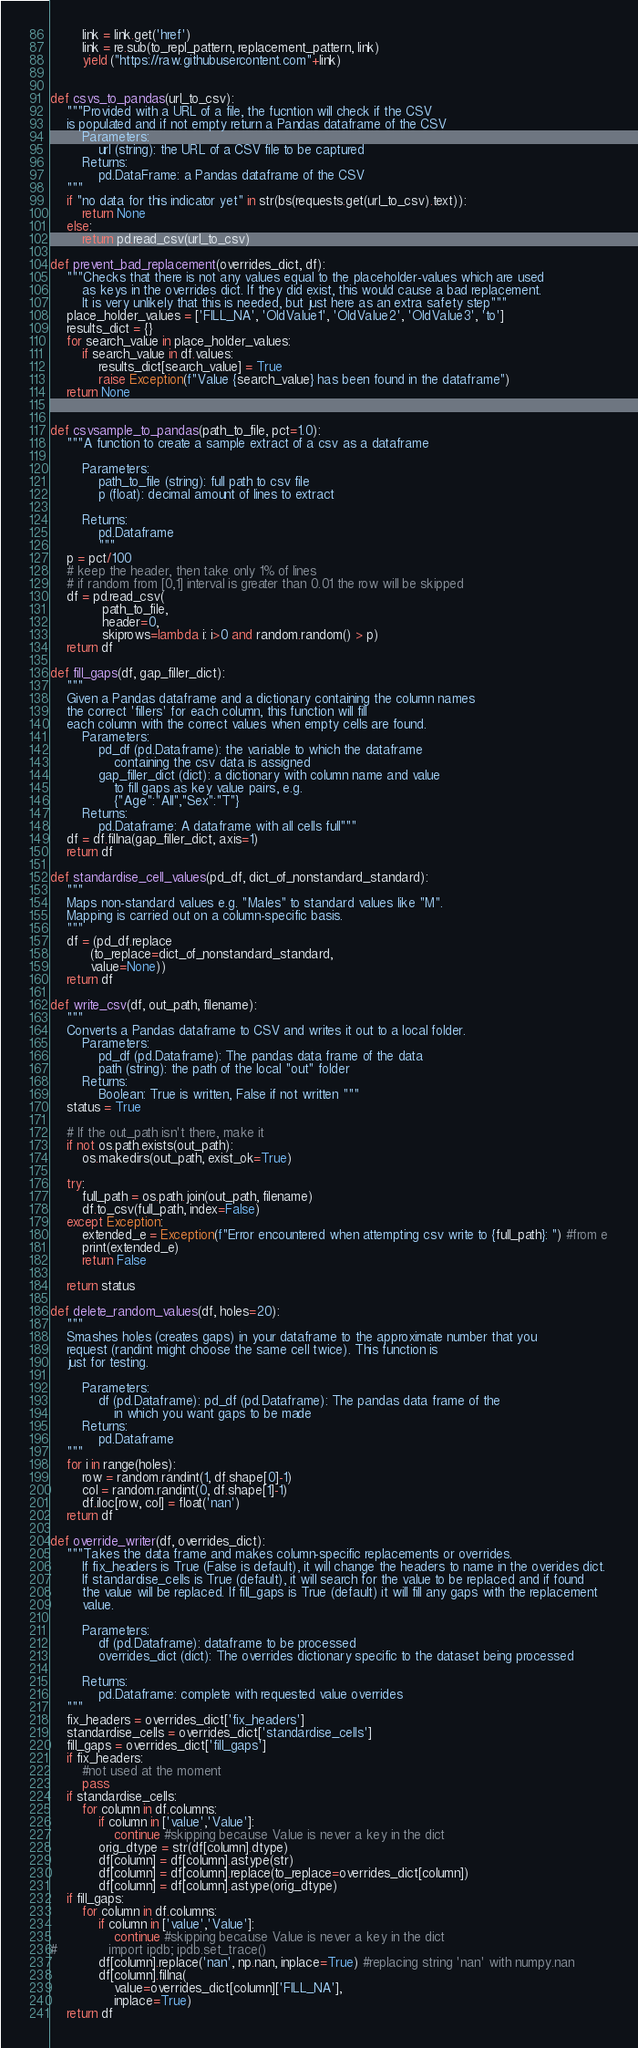Convert code to text. <code><loc_0><loc_0><loc_500><loc_500><_Python_>        link = link.get('href')
        link = re.sub(to_repl_pattern, replacement_pattern, link)
        yield ("https://raw.githubusercontent.com"+link)


def csvs_to_pandas(url_to_csv):
    """Provided with a URL of a file, the fucntion will check if the CSV
    is populated and if not empty return a Pandas dataframe of the CSV
        Parameters:
            url (string): the URL of a CSV file to be captured
        Returns:
            pd.DataFrame: a Pandas dataframe of the CSV
    """
    if "no data for this indicator yet" in str(bs(requests.get(url_to_csv).text)):
        return None
    else:
        return pd.read_csv(url_to_csv)

def prevent_bad_replacement(overrides_dict, df):
    """Checks that there is not any values equal to the placeholder-values which are used 
        as keys in the overrides dict. If they did exist, this would cause a bad replacement.
        It is very unlikely that this is needed, but just here as an extra safety step"""
    place_holder_values = ['FILL_NA', 'OldValue1', 'OldValue2', 'OldValue3', 'to']
    results_dict = {}
    for search_value in place_holder_values:
        if search_value in df.values:
            results_dict[search_value] = True
            raise Exception(f"Value {search_value} has been found in the dataframe")
    return None


def csvsample_to_pandas(path_to_file, pct=1.0):
    """A function to create a sample extract of a csv as a dataframe
    
        Parameters:
            path_to_file (string): full path to csv file
            p (float): decimal amount of lines to extract
            
        Returns:
            pd.Dataframe
            """
    p = pct/100  
    # keep the header, then take only 1% of lines
    # if random from [0,1] interval is greater than 0.01 the row will be skipped
    df = pd.read_csv(
             path_to_file,
             header=0,
             skiprows=lambda i: i>0 and random.random() > p)
    return df

def fill_gaps(df, gap_filler_dict):
    """
    Given a Pandas dataframe and a dictionary containing the column names
    the correct 'fillers' for each column, this function will fill
    each column with the correct values when empty cells are found.
        Parameters:
            pd_df (pd.Dataframe): the variable to which the dataframe 
                containing the csv data is assigned
            gap_filler_dict (dict): a dictionary with column name and value 
                to fill gaps as key value pairs, e.g.
                {"Age":"All","Sex":"T"}
        Returns:
            pd.Dataframe: A dataframe with all cells full"""
    df = df.fillna(gap_filler_dict, axis=1)
    return df

def standardise_cell_values(pd_df, dict_of_nonstandard_standard):
    """
    Maps non-standard values e.g. "Males" to standard values like "M".
    Mapping is carried out on a column-specific basis.
    """
    df = (pd_df.replace
          (to_replace=dict_of_nonstandard_standard,
          value=None))
    return df

def write_csv(df, out_path, filename):
    """
    Converts a Pandas dataframe to CSV and writes it out to a local folder.
        Parameters:
            pd_df (pd.Dataframe): The pandas data frame of the data
            path (string): the path of the local "out" folder
        Returns:
            Boolean: True is written, False if not written """ 
    status = True

    # If the out_path isn't there, make it
    if not os.path.exists(out_path):
        os.makedirs(out_path, exist_ok=True)

    try:
        full_path = os.path.join(out_path, filename)
        df.to_csv(full_path, index=False)
    except Exception:
        extended_e = Exception(f"Error encountered when attempting csv write to {full_path}: ") #from e
        print(extended_e)
        return False

    return status

def delete_random_values(df, holes=20):
    """
    Smashes holes (creates gaps) in your dataframe to the approximate number that you
    request (randint might choose the same cell twice). This function is 
    just for testing. 

        Parameters:
            df (pd.Dataframe): pd_df (pd.Dataframe): The pandas data frame of the 
                in which you want gaps to be made
        Returns: 
            pd.Dataframe
    """
    for i in range(holes):
        row = random.randint(1, df.shape[0]-1)
        col = random.randint(0, df.shape[1]-1)
        df.iloc[row, col] = float('nan')
    return df

def override_writer(df, overrides_dict):
    """Takes the data frame and makes column-specific replacements or overrides. 
        If fix_headers is True (False is default), it will change the headers to name in the overides dict. 
        If standardise_cells is True (default), it will search for the value to be replaced and if found
        the value will be replaced. If fill_gaps is True (default) it will fill any gaps with the replacement
        value. 
        
        Parameters:
            df (pd.Dataframe): dataframe to be processed
            overrides_dict (dict): The overrides dictionary specific to the dataset being processed
            
        Returns:
            pd.Dataframe: complete with requested value overrides 
    """
    fix_headers = overrides_dict['fix_headers']
    standardise_cells = overrides_dict['standardise_cells']
    fill_gaps = overrides_dict['fill_gaps']
    if fix_headers:
        #not used at the moment
        pass
    if standardise_cells:
        for column in df.columns:
            if column in ['value','Value']: 
                continue #skipping because Value is never a key in the dict
            orig_dtype = str(df[column].dtype)
            df[column] = df[column].astype(str)
            df[column] = df[column].replace(to_replace=overrides_dict[column])
            df[column] = df[column].astype(orig_dtype)
    if fill_gaps:
        for column in df.columns:
            if column in ['value','Value']: 
                continue #skipping because Value is never a key in the dict
#             import ipdb; ipdb.set_trace()
            df[column].replace('nan', np.nan, inplace=True) #replacing string 'nan' with numpy.nan
            df[column].fillna(
                value=overrides_dict[column]['FILL_NA'],
                inplace=True)
    return df</code> 